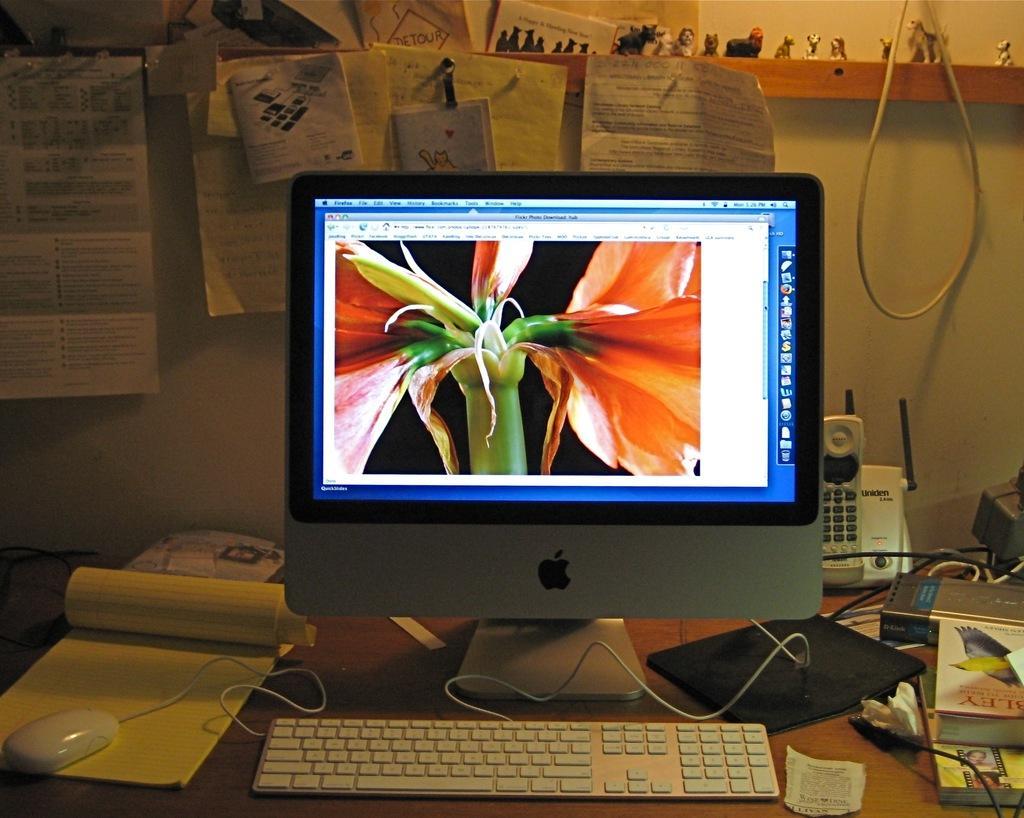Could you give a brief overview of what you see in this image? In the foreground of the image we can see a table on which a computer, mouse, phone and books are there. On the top of the image we can see some papers and small statues. 